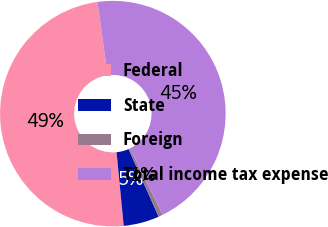Convert chart. <chart><loc_0><loc_0><loc_500><loc_500><pie_chart><fcel>Federal<fcel>State<fcel>Foreign<fcel>Total income tax expense<nl><fcel>49.36%<fcel>5.12%<fcel>0.64%<fcel>44.88%<nl></chart> 